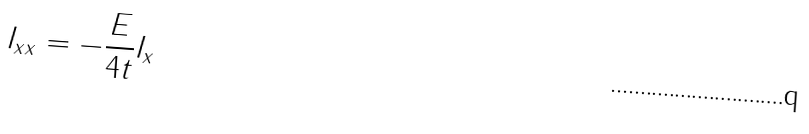Convert formula to latex. <formula><loc_0><loc_0><loc_500><loc_500>I _ { x x } = - \frac { E } { 4 t } I _ { x }</formula> 